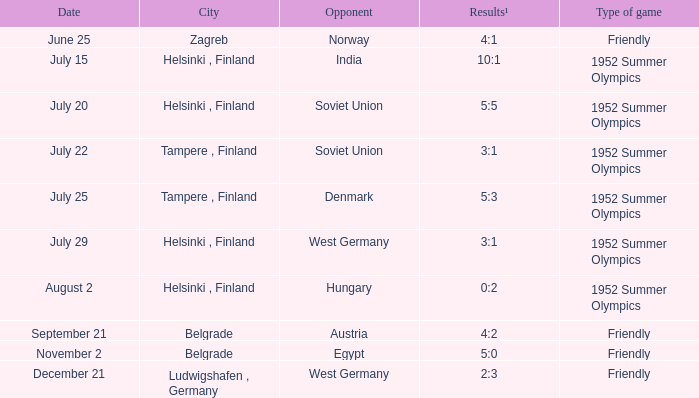What is the Results¹ that was a friendly game and played on June 25? 4:1. 